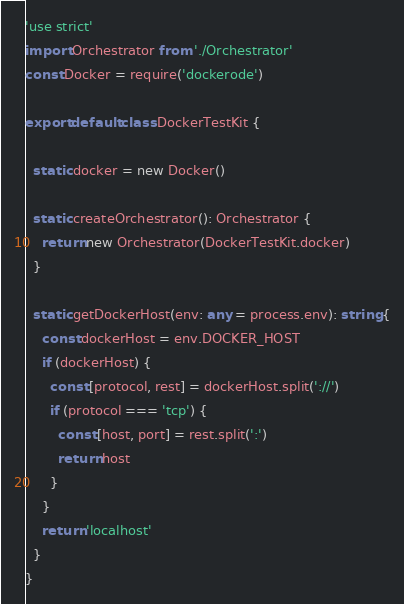Convert code to text. <code><loc_0><loc_0><loc_500><loc_500><_TypeScript_>'use strict'
import Orchestrator from './Orchestrator'
const Docker = require('dockerode')

export default class DockerTestKit {

  static docker = new Docker()

  static createOrchestrator(): Orchestrator {
    return new Orchestrator(DockerTestKit.docker)
  }

  static getDockerHost(env: any = process.env): string {
    const dockerHost = env.DOCKER_HOST
    if (dockerHost) {
      const [protocol, rest] = dockerHost.split('://')
      if (protocol === 'tcp') {
        const [host, port] = rest.split(':') 
        return host
      }
    }
    return 'localhost'
  }
}
</code> 